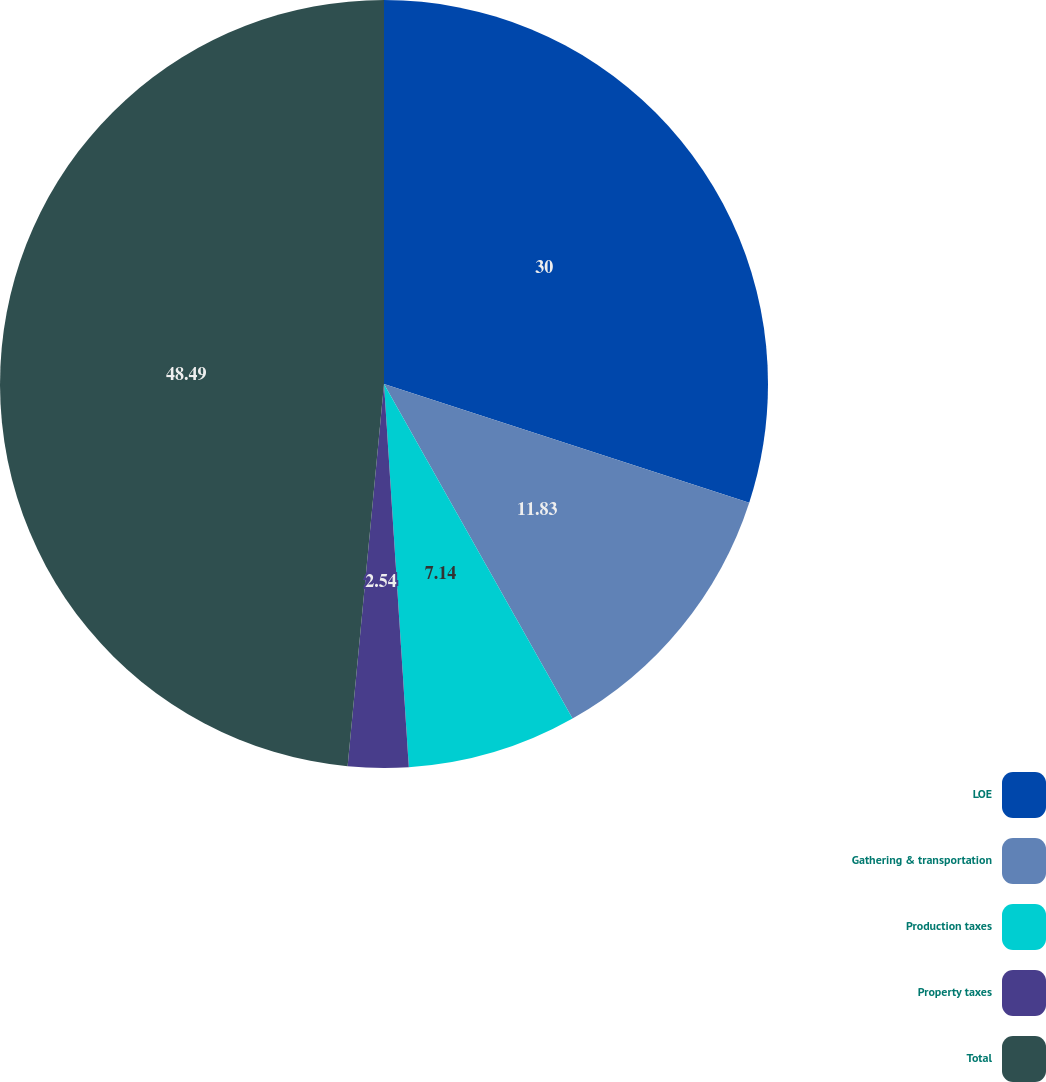<chart> <loc_0><loc_0><loc_500><loc_500><pie_chart><fcel>LOE<fcel>Gathering & transportation<fcel>Production taxes<fcel>Property taxes<fcel>Total<nl><fcel>30.0%<fcel>11.83%<fcel>7.14%<fcel>2.54%<fcel>48.49%<nl></chart> 